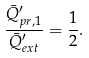<formula> <loc_0><loc_0><loc_500><loc_500>\frac { \bar { Q } ^ { \prime } _ { p r , 1 } } { \bar { Q } ^ { \prime } _ { e x t } } = \frac { 1 } { 2 } .</formula> 